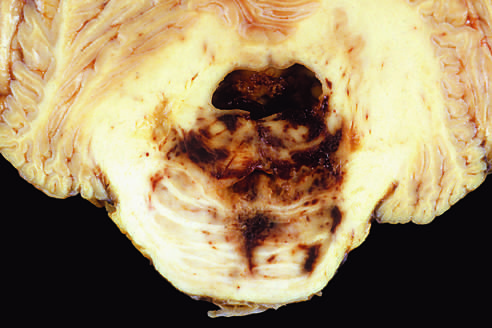s there disruption of the vessels that enter the pons along the midline, leading to hemorrhage?
Answer the question using a single word or phrase. Yes 